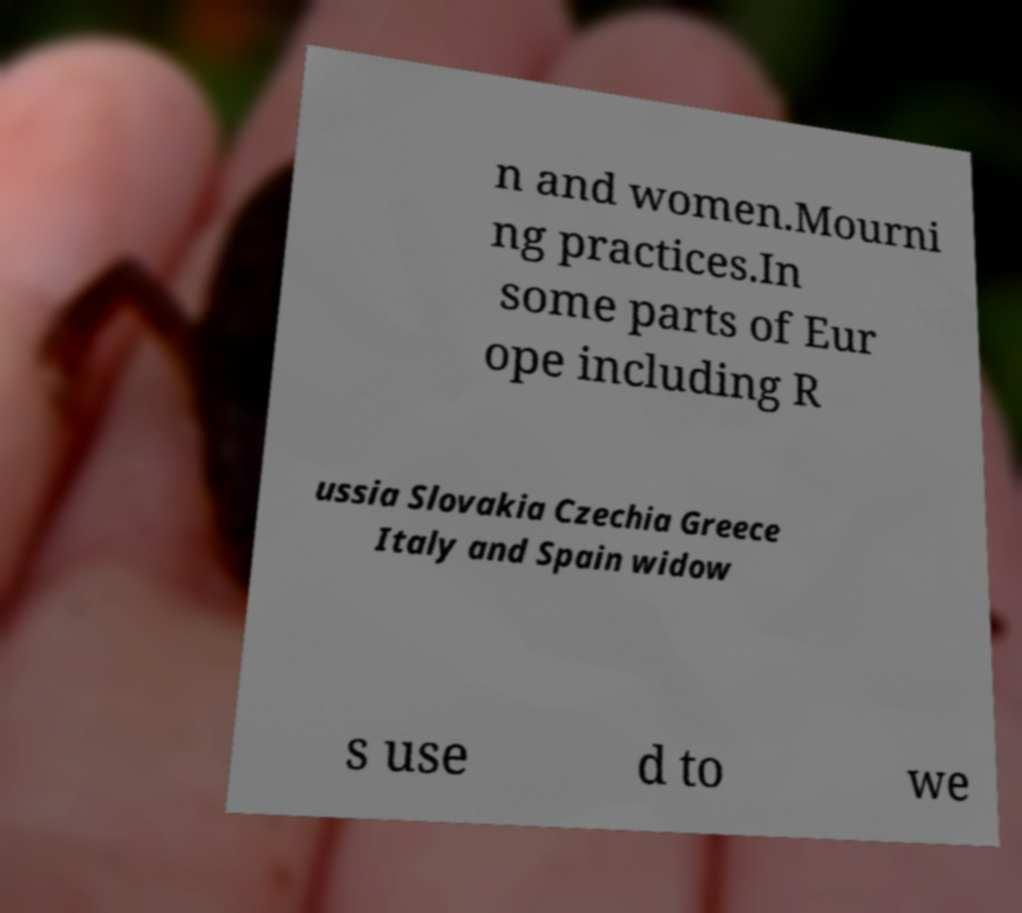For documentation purposes, I need the text within this image transcribed. Could you provide that? n and women.Mourni ng practices.In some parts of Eur ope including R ussia Slovakia Czechia Greece Italy and Spain widow s use d to we 